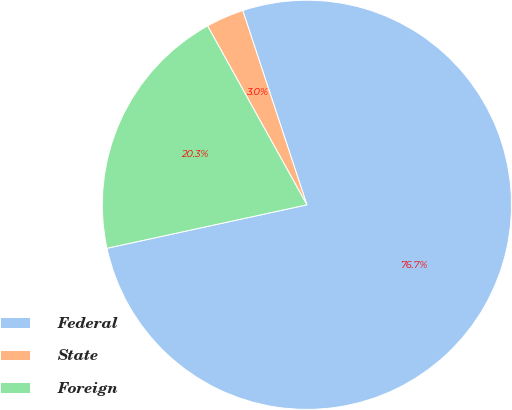Convert chart. <chart><loc_0><loc_0><loc_500><loc_500><pie_chart><fcel>Federal<fcel>State<fcel>Foreign<nl><fcel>76.67%<fcel>2.99%<fcel>20.34%<nl></chart> 